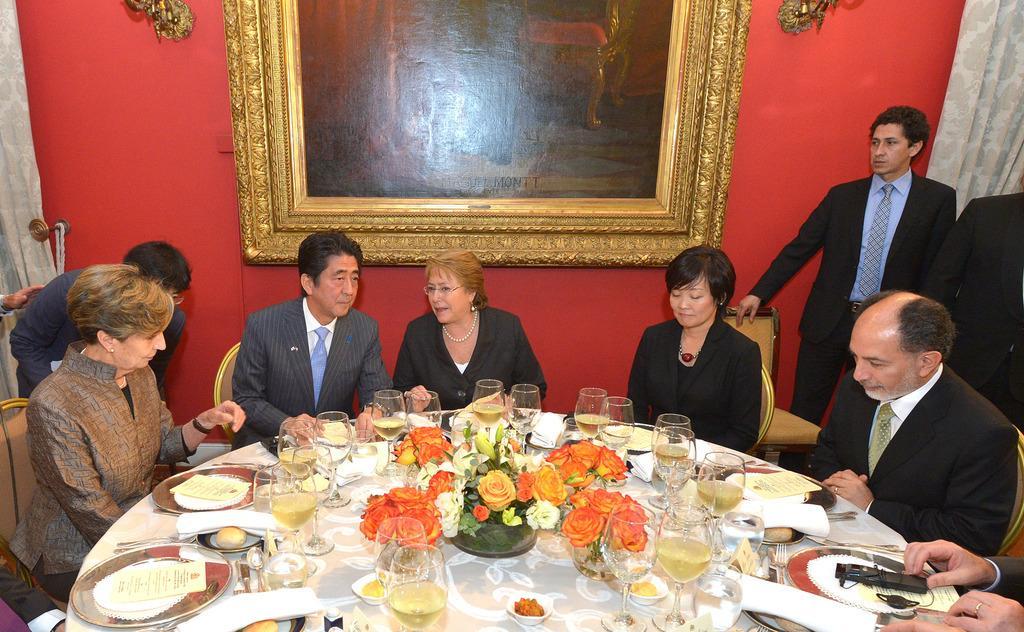Could you give a brief overview of what you see in this image? In this image there are group of persons sitting around the dining table and having their food and drinks and there are also flowers on the dining table and at the background there is a painting which is attached to the red color wall. 